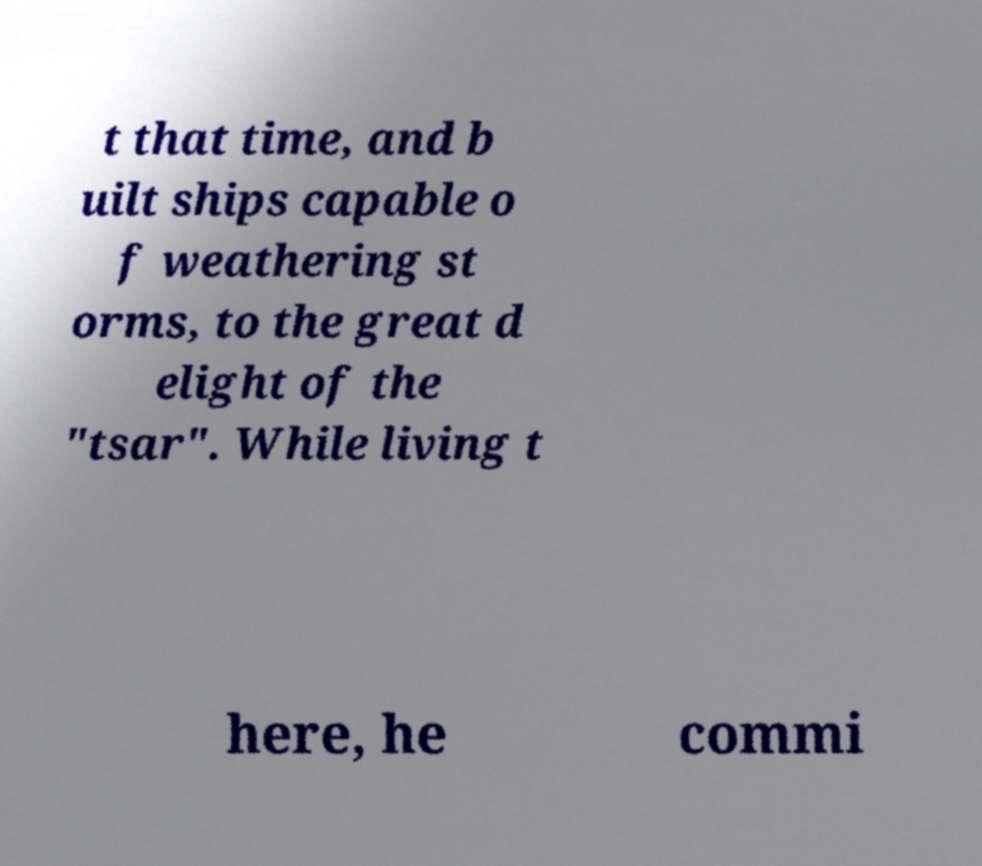I need the written content from this picture converted into text. Can you do that? t that time, and b uilt ships capable o f weathering st orms, to the great d elight of the "tsar". While living t here, he commi 